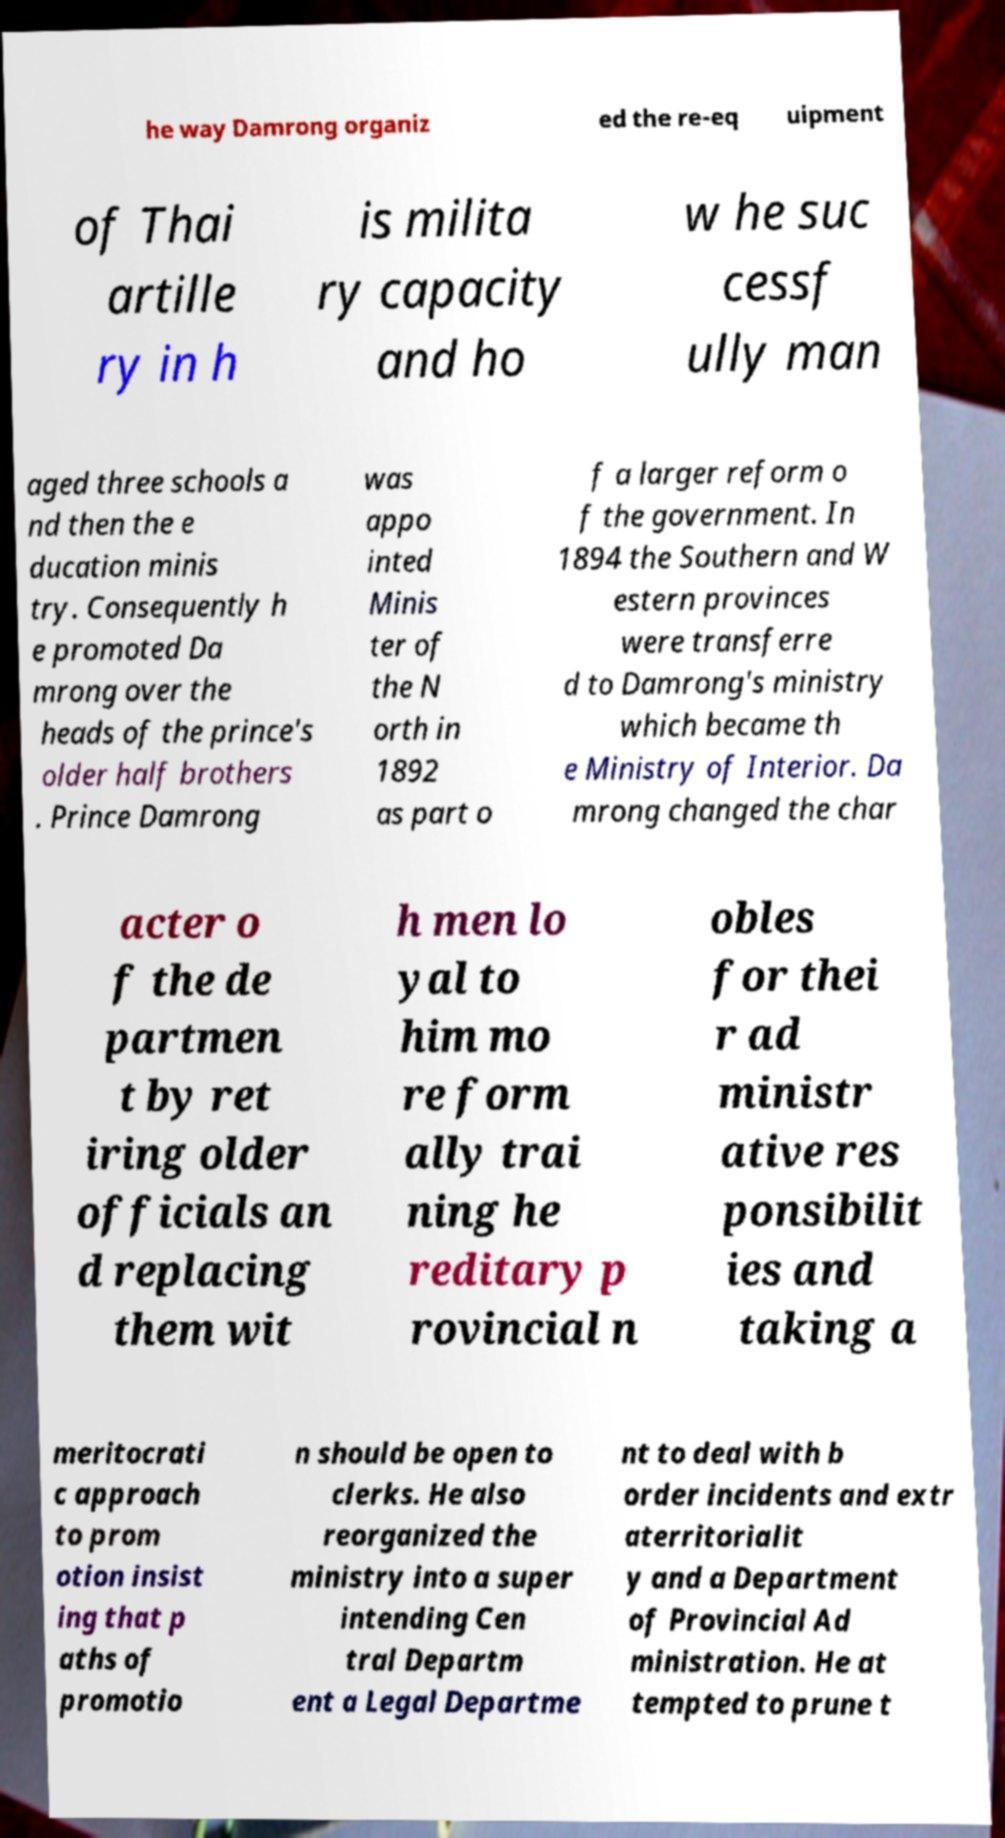Can you accurately transcribe the text from the provided image for me? he way Damrong organiz ed the re-eq uipment of Thai artille ry in h is milita ry capacity and ho w he suc cessf ully man aged three schools a nd then the e ducation minis try. Consequently h e promoted Da mrong over the heads of the prince's older half brothers . Prince Damrong was appo inted Minis ter of the N orth in 1892 as part o f a larger reform o f the government. In 1894 the Southern and W estern provinces were transferre d to Damrong's ministry which became th e Ministry of Interior. Da mrong changed the char acter o f the de partmen t by ret iring older officials an d replacing them wit h men lo yal to him mo re form ally trai ning he reditary p rovincial n obles for thei r ad ministr ative res ponsibilit ies and taking a meritocrati c approach to prom otion insist ing that p aths of promotio n should be open to clerks. He also reorganized the ministry into a super intending Cen tral Departm ent a Legal Departme nt to deal with b order incidents and extr aterritorialit y and a Department of Provincial Ad ministration. He at tempted to prune t 